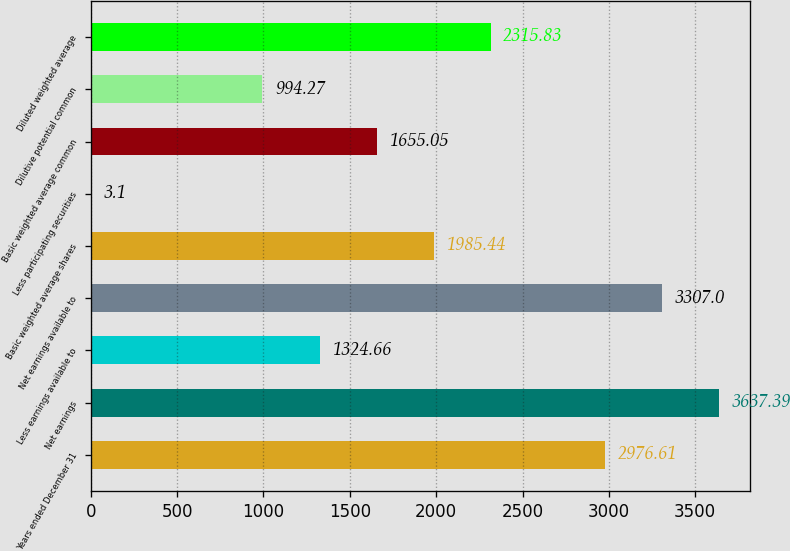Convert chart to OTSL. <chart><loc_0><loc_0><loc_500><loc_500><bar_chart><fcel>Years ended December 31<fcel>Net earnings<fcel>Less earnings available to<fcel>Net earnings available to<fcel>Basic weighted average shares<fcel>Less participating securities<fcel>Basic weighted average common<fcel>Dilutive potential common<fcel>Diluted weighted average<nl><fcel>2976.61<fcel>3637.39<fcel>1324.66<fcel>3307<fcel>1985.44<fcel>3.1<fcel>1655.05<fcel>994.27<fcel>2315.83<nl></chart> 